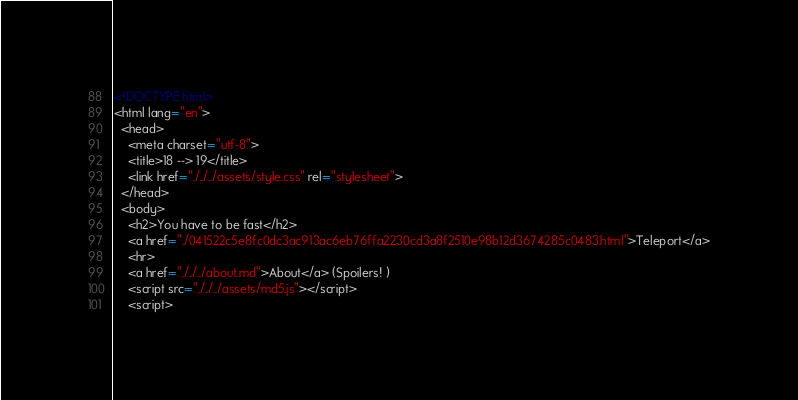<code> <loc_0><loc_0><loc_500><loc_500><_HTML_><!DOCTYPE html>
<html lang="en">
  <head>
    <meta charset="utf-8">
    <title>18 --> 19</title>
    <link href="./../../assets/style.css" rel="stylesheet">
  </head>
  <body>
    <h2>You have to be fast</h2>
    <a href="./041522c5e8fc0dc3ac913ac6eb76ffa2230cd3a8f2510e98b12d3674285c0483.html">Teleport</a>
    <hr>
    <a href="./../../about.md">About</a> (Spoilers! )
    <script src="./../../assets/md5.js"></script>
    <script></code> 